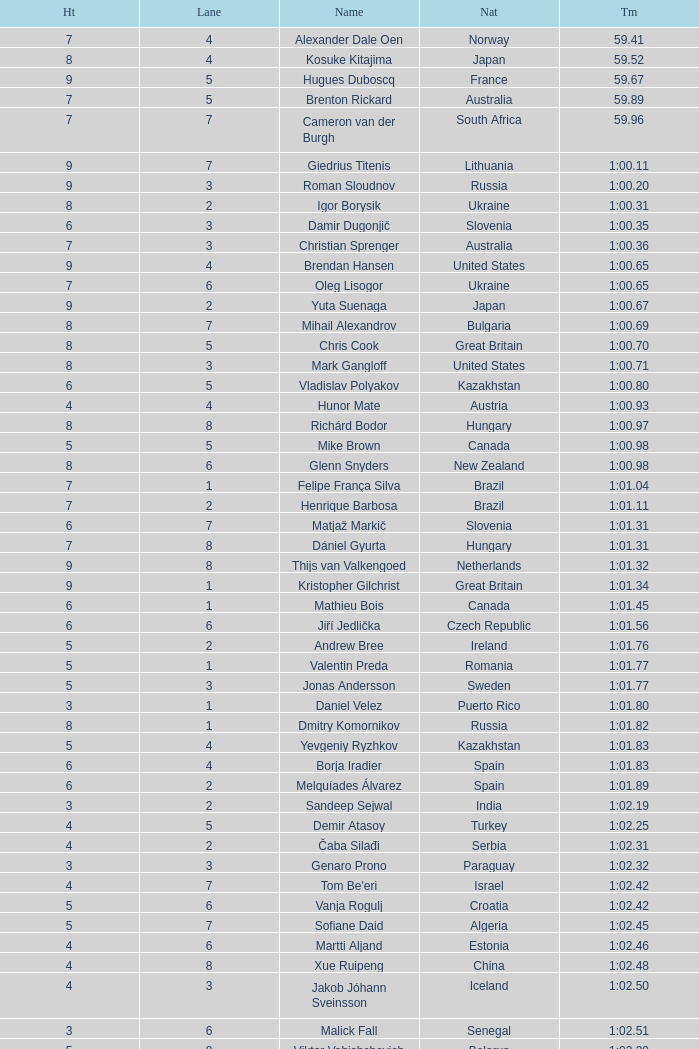What is the smallest lane number of Xue Ruipeng? 8.0. 